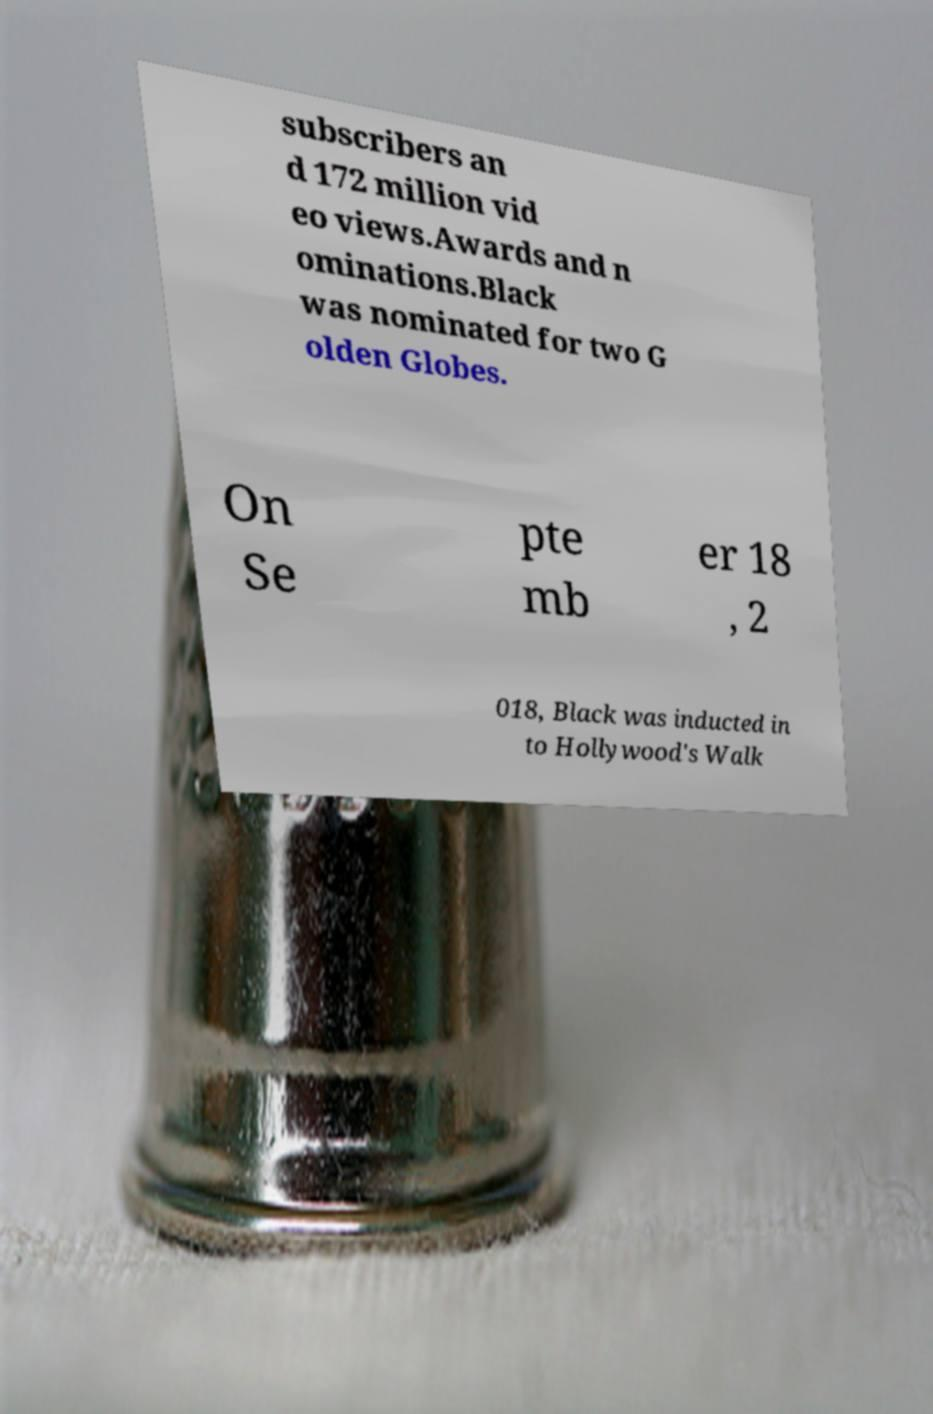There's text embedded in this image that I need extracted. Can you transcribe it verbatim? subscribers an d 172 million vid eo views.Awards and n ominations.Black was nominated for two G olden Globes. On Se pte mb er 18 , 2 018, Black was inducted in to Hollywood's Walk 